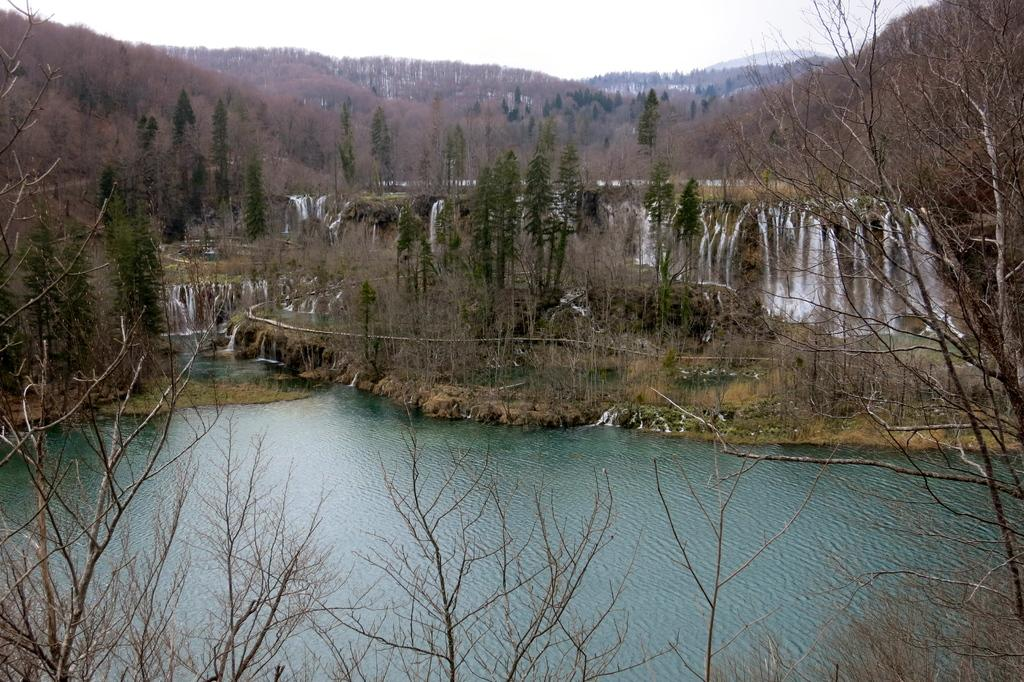What type of vegetation can be seen in the image? There are trees in the image. Can you describe the condition of some of the trees? Some of the trees appear to be dry. What natural feature is present in the image? There is a waterfall in the image. What else can be seen in the image besides the trees and waterfall? There is water visible in the image. What is the color of the sky in the image? The sky is white in color. What type of whip can be seen in the image? There is no whip present in the image. What type of grass is growing near the waterfall in the image? There is no grass visible in the image; only trees and water are present. 